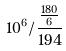<formula> <loc_0><loc_0><loc_500><loc_500>1 0 ^ { 6 } / \frac { \frac { 1 8 0 } { 6 } } { 1 9 4 }</formula> 